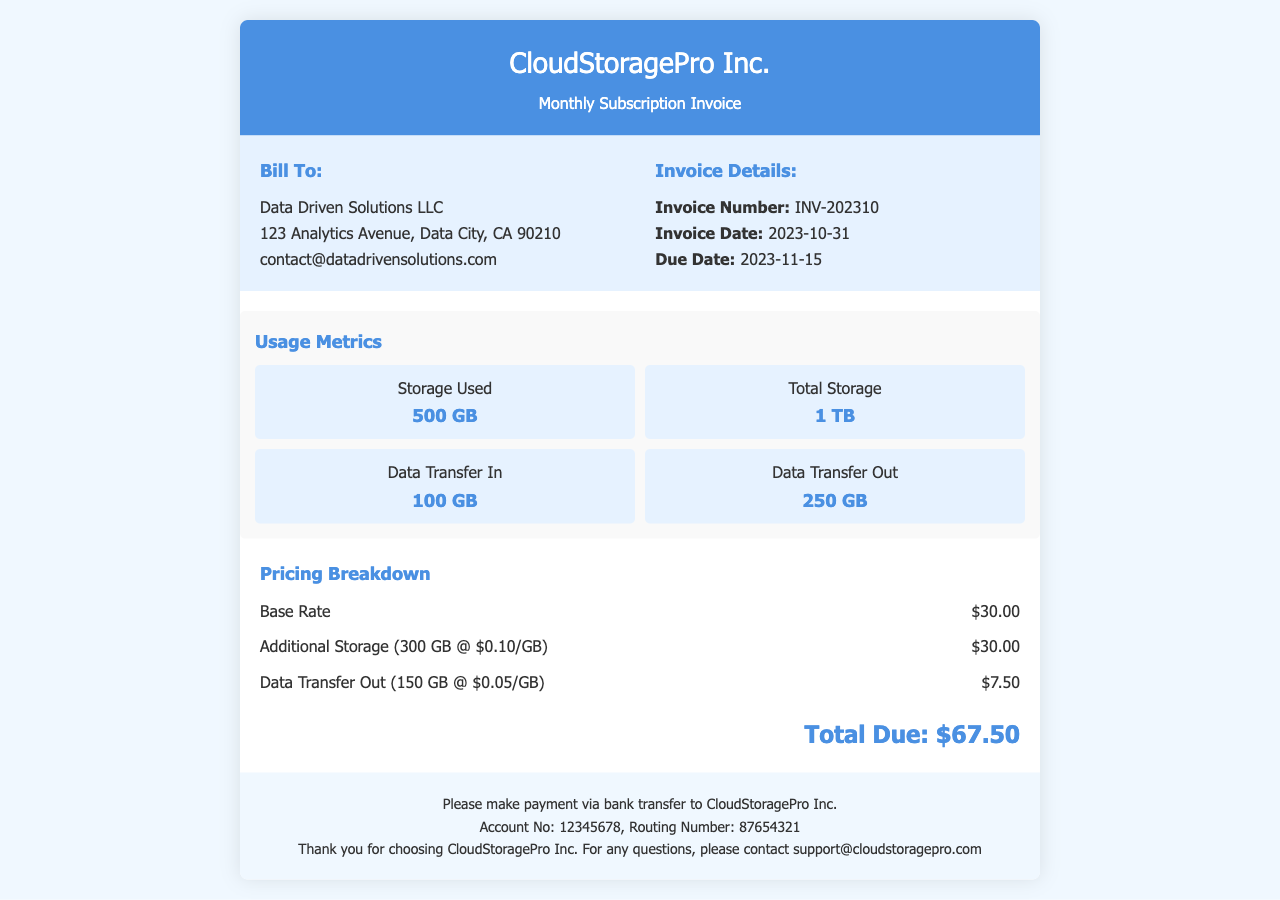What is the invoice number? The invoice number can be found in the invoice details section, which is labeled as "Invoice Number".
Answer: INV-202310 What is the total storage available? The total storage is listed under usage metrics, specifically labeled as "Total Storage".
Answer: 1 TB When is the invoice due date? The due date is provided under the invoice details section, specifically labeled as "Due Date".
Answer: 2023-11-15 How much was charged for additional storage? The charge for additional storage can be found in the pricing breakdown, specifically labeled as "Additional Storage".
Answer: $30.00 What is the data transfer out amount? The data transfer out amount is listed under usage metrics, specifically labeled as "Data Transfer Out".
Answer: 250 GB What is the base rate for the subscription? The base rate is provided in the pricing breakdown, specifically labeled as "Base Rate".
Answer: $30.00 What is the total amount due? The total amount due is prominently displayed at the bottom of the pricing section, labeled as "Total Due".
Answer: $67.50 Who is the billing recipient? The billing recipient's information is shown under the "Bill To" section.
Answer: Data Driven Solutions LLC 